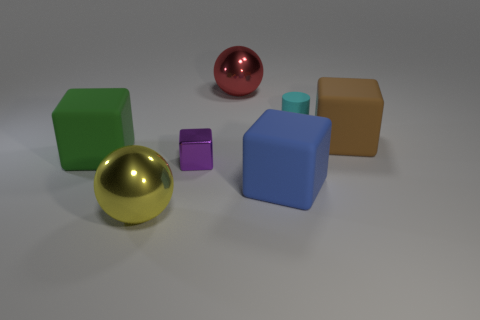Add 1 red metallic balls. How many objects exist? 8 Subtract all cylinders. How many objects are left? 6 Subtract all blue matte objects. Subtract all large red rubber blocks. How many objects are left? 6 Add 7 blue rubber blocks. How many blue rubber blocks are left? 8 Add 7 big red things. How many big red things exist? 8 Subtract 0 blue balls. How many objects are left? 7 